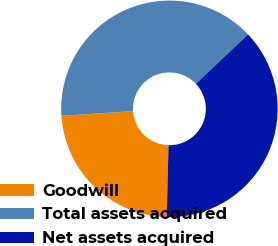Convert chart. <chart><loc_0><loc_0><loc_500><loc_500><pie_chart><fcel>Goodwill<fcel>Total assets acquired<fcel>Net assets acquired<nl><fcel>23.58%<fcel>38.97%<fcel>37.45%<nl></chart> 